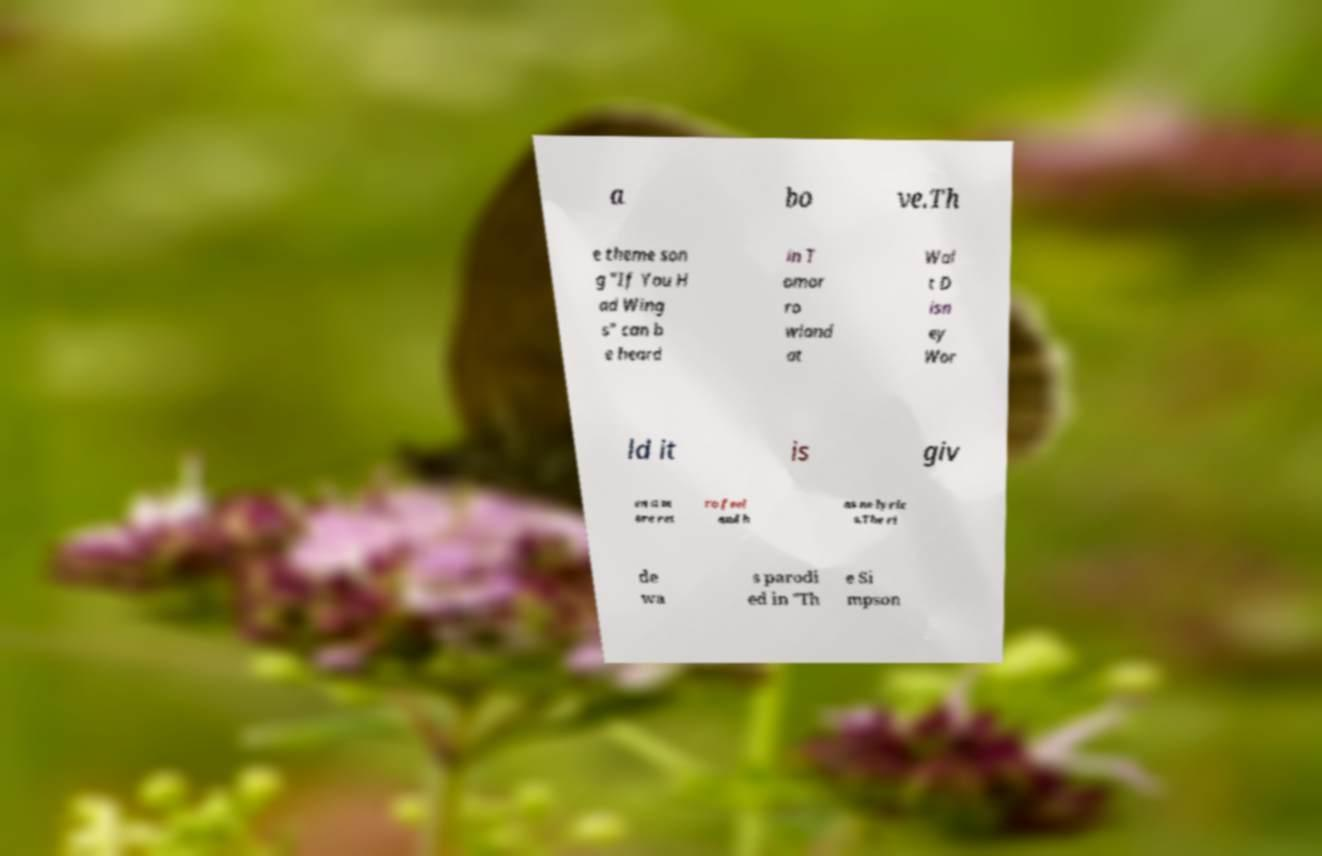Could you assist in decoding the text presented in this image and type it out clearly? a bo ve.Th e theme son g "If You H ad Wing s" can b e heard in T omor ro wland at Wal t D isn ey Wor ld it is giv en a m ore ret ro feel and h as no lyric s.The ri de wa s parodi ed in "Th e Si mpson 